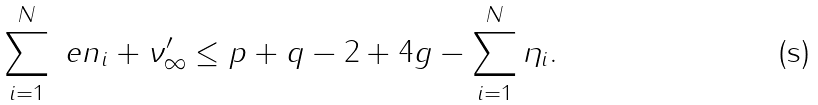Convert formula to latex. <formula><loc_0><loc_0><loc_500><loc_500>\sum _ { i = 1 } ^ { N } \ e n _ { i } + \nu ^ { \prime } _ { \infty } \leq p + q - 2 + 4 g - \sum _ { i = 1 } ^ { N } \eta _ { i } .</formula> 